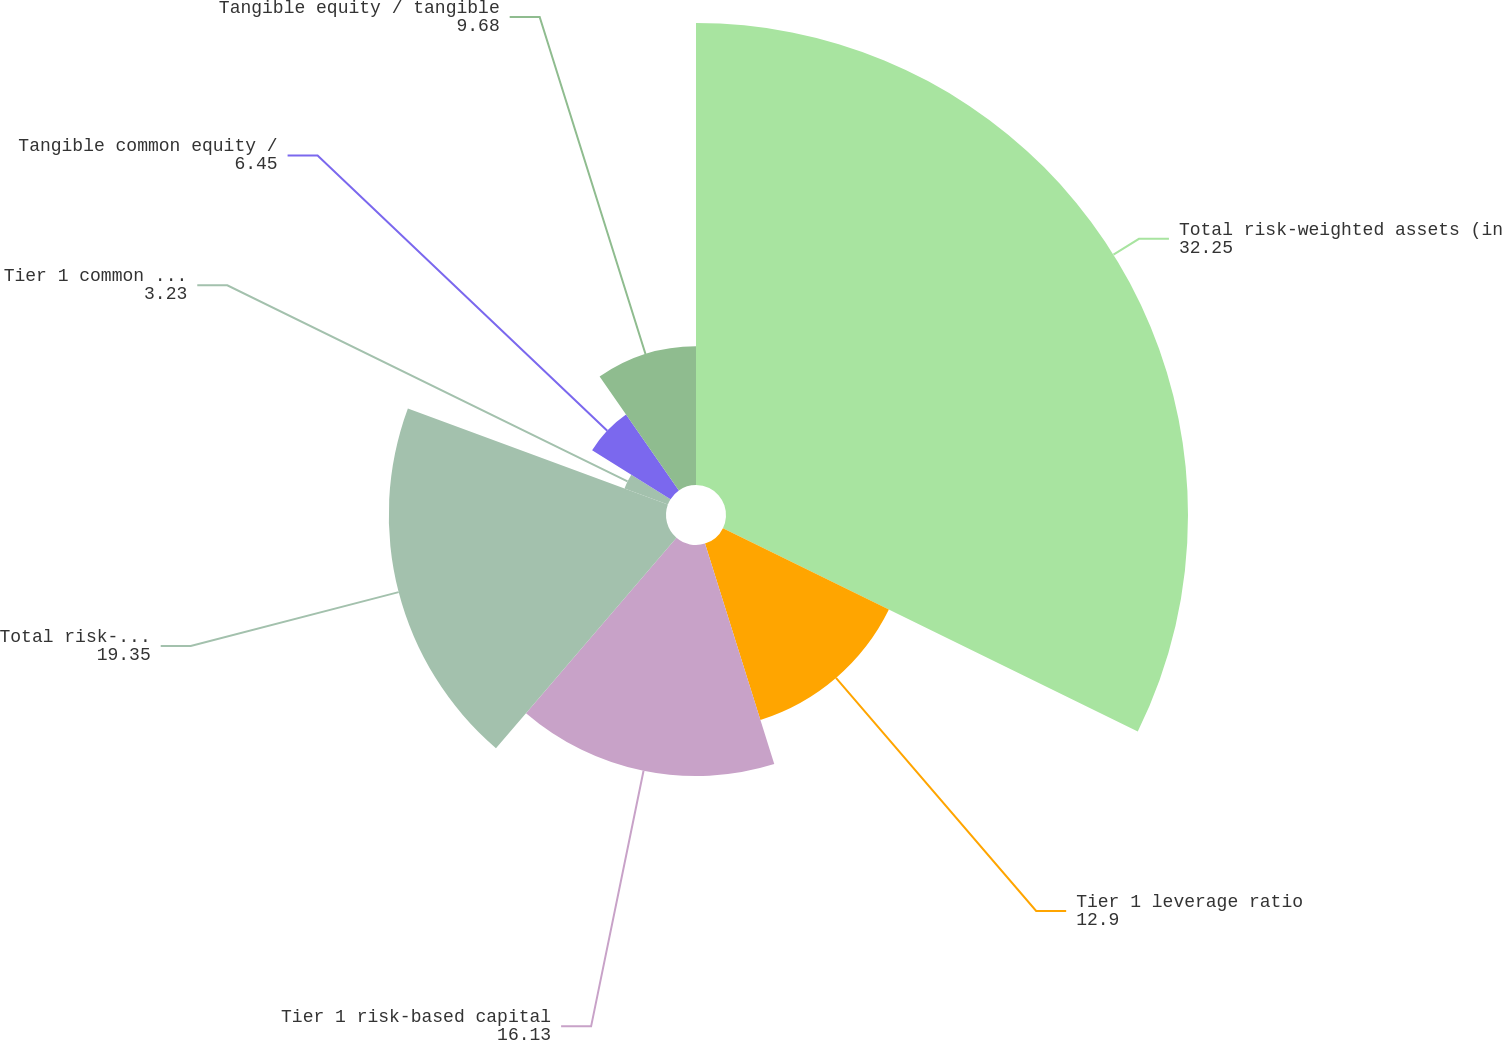Convert chart. <chart><loc_0><loc_0><loc_500><loc_500><pie_chart><fcel>Total risk-weighted assets (in<fcel>Tier 1 leverage ratio<fcel>Tier 1 risk-based capital<fcel>Total risk-based capital ratio<fcel>Tier 1 common risk-based<fcel>Tangible common equity /<fcel>Tangible equity / tangible<nl><fcel>32.25%<fcel>12.9%<fcel>16.13%<fcel>19.35%<fcel>3.23%<fcel>6.45%<fcel>9.68%<nl></chart> 